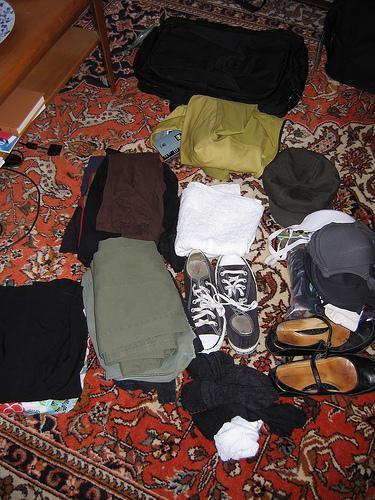How many pairs of shoes are shown?
Give a very brief answer. 2. How many of these shoes have laces?
Give a very brief answer. 2. 